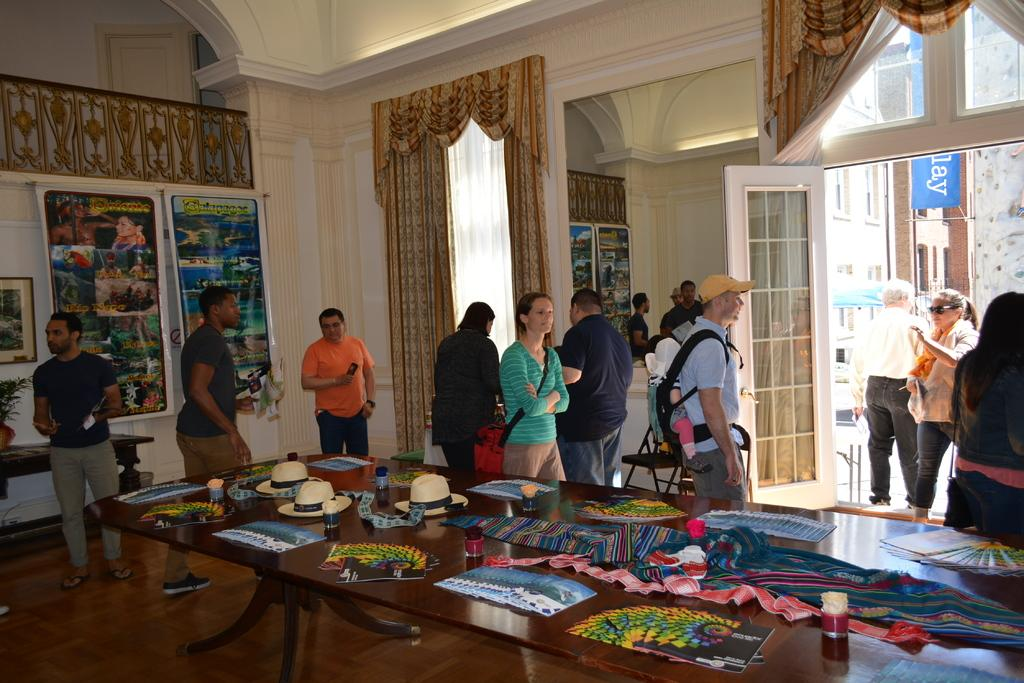What type of table is in the image? There is a wooden table in the image. What is on top of the table? A hat and clothes are on the table. Are there any people in the image? Yes, there are people standing in the image. What type of cannon is being used by the people in the image? There is no cannon present in the image; it features a wooden table with a hat and clothes, along with people standing nearby. What type of canvas is being used by the people in the image? There is no canvas present in the image; it features a wooden table with a hat and clothes, along with people standing nearby. 